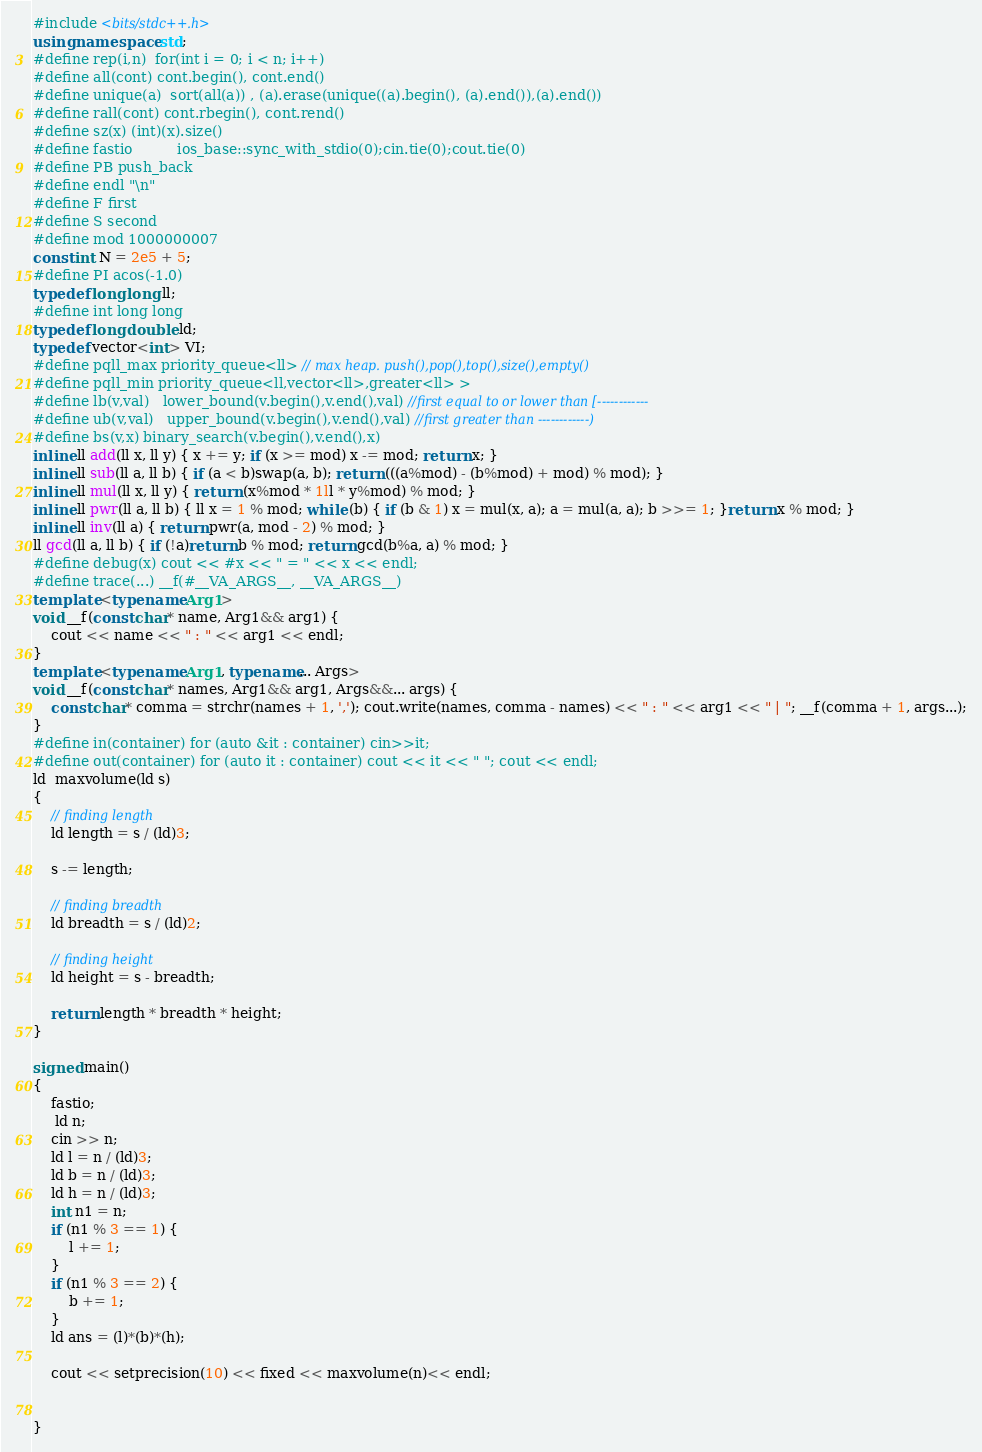Convert code to text. <code><loc_0><loc_0><loc_500><loc_500><_C++_>#include <bits/stdc++.h>
using namespace std;
#define rep(i,n)  for(int i = 0; i < n; i++)
#define all(cont) cont.begin(), cont.end()
#define unique(a)  sort(all(a)) , (a).erase(unique((a).begin(), (a).end()),(a).end())
#define rall(cont) cont.rbegin(), cont.rend()
#define sz(x) (int)(x).size()
#define fastio          ios_base::sync_with_stdio(0);cin.tie(0);cout.tie(0)
#define PB push_back
#define endl "\n"
#define F first
#define S second
#define mod 1000000007
const int N = 2e5 + 5;
#define PI acos(-1.0)
typedef long long ll;
#define int long long
typedef long double ld;
typedef vector<int> VI;
#define pqll_max priority_queue<ll> // max heap. push(),pop(),top(),size(),empty()
#define pqll_min priority_queue<ll,vector<ll>,greater<ll> >
#define lb(v,val)   lower_bound(v.begin(),v.end(),val) //first equal to or lower than [------------
#define ub(v,val)   upper_bound(v.begin(),v.end(),val) //first greater than ------------)
#define bs(v,x) binary_search(v.begin(),v.end(),x)
inline ll add(ll x, ll y) { x += y; if (x >= mod) x -= mod; return x; }
inline ll sub(ll a, ll b) { if (a < b)swap(a, b); return (((a%mod) - (b%mod) + mod) % mod); }
inline ll mul(ll x, ll y) { return (x%mod * 1ll * y%mod) % mod; }
inline ll pwr(ll a, ll b) { ll x = 1 % mod; while (b) { if (b & 1) x = mul(x, a); a = mul(a, a); b >>= 1; }return x % mod; }
inline ll inv(ll a) { return pwr(a, mod - 2) % mod; }
ll gcd(ll a, ll b) { if (!a)return b % mod; return gcd(b%a, a) % mod; }
#define debug(x) cout << #x << " = " << x << endl;
#define trace(...) __f(#__VA_ARGS__, __VA_ARGS__)
template <typename Arg1>
void __f(const char* name, Arg1&& arg1) {
	cout << name << " : " << arg1 << endl;
}
template <typename Arg1, typename... Args>
void __f(const char* names, Arg1&& arg1, Args&&... args) {
	const char* comma = strchr(names + 1, ','); cout.write(names, comma - names) << " : " << arg1 << " | "; __f(comma + 1, args...);
}
#define in(container) for (auto &it : container) cin>>it;
#define out(container) for (auto it : container) cout << it << " "; cout << endl;
ld  maxvolume(ld s)
{
	// finding length 
	ld length = s / (ld)3;

	s -= length;

	// finding breadth 
	ld breadth = s / (ld)2;

	// finding height 
	ld height = s - breadth;

	return length * breadth * height;
}

signed main()
{
	fastio;
	 ld n;
	cin >> n;
	ld l = n / (ld)3;
	ld b = n / (ld)3;
	ld h = n / (ld)3;
	int n1 = n;
	if (n1 % 3 == 1) {
		l += 1;
	}
	if (n1 % 3 == 2) {
		b += 1;
	}
	ld ans = (l)*(b)*(h);

	cout << setprecision(10) << fixed << maxvolume(n)<< endl;


}</code> 